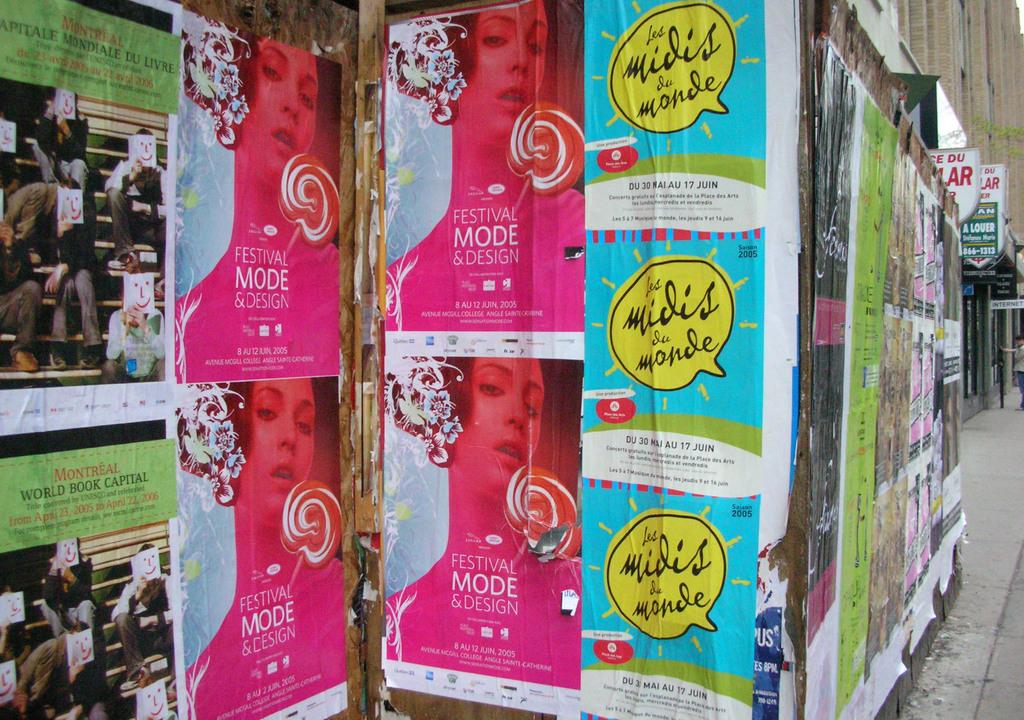What is the word under festival in bold font?
Offer a very short reply. Mode. What os written in the yellow word bubble?
Your response must be concise. Les midis du monde. 